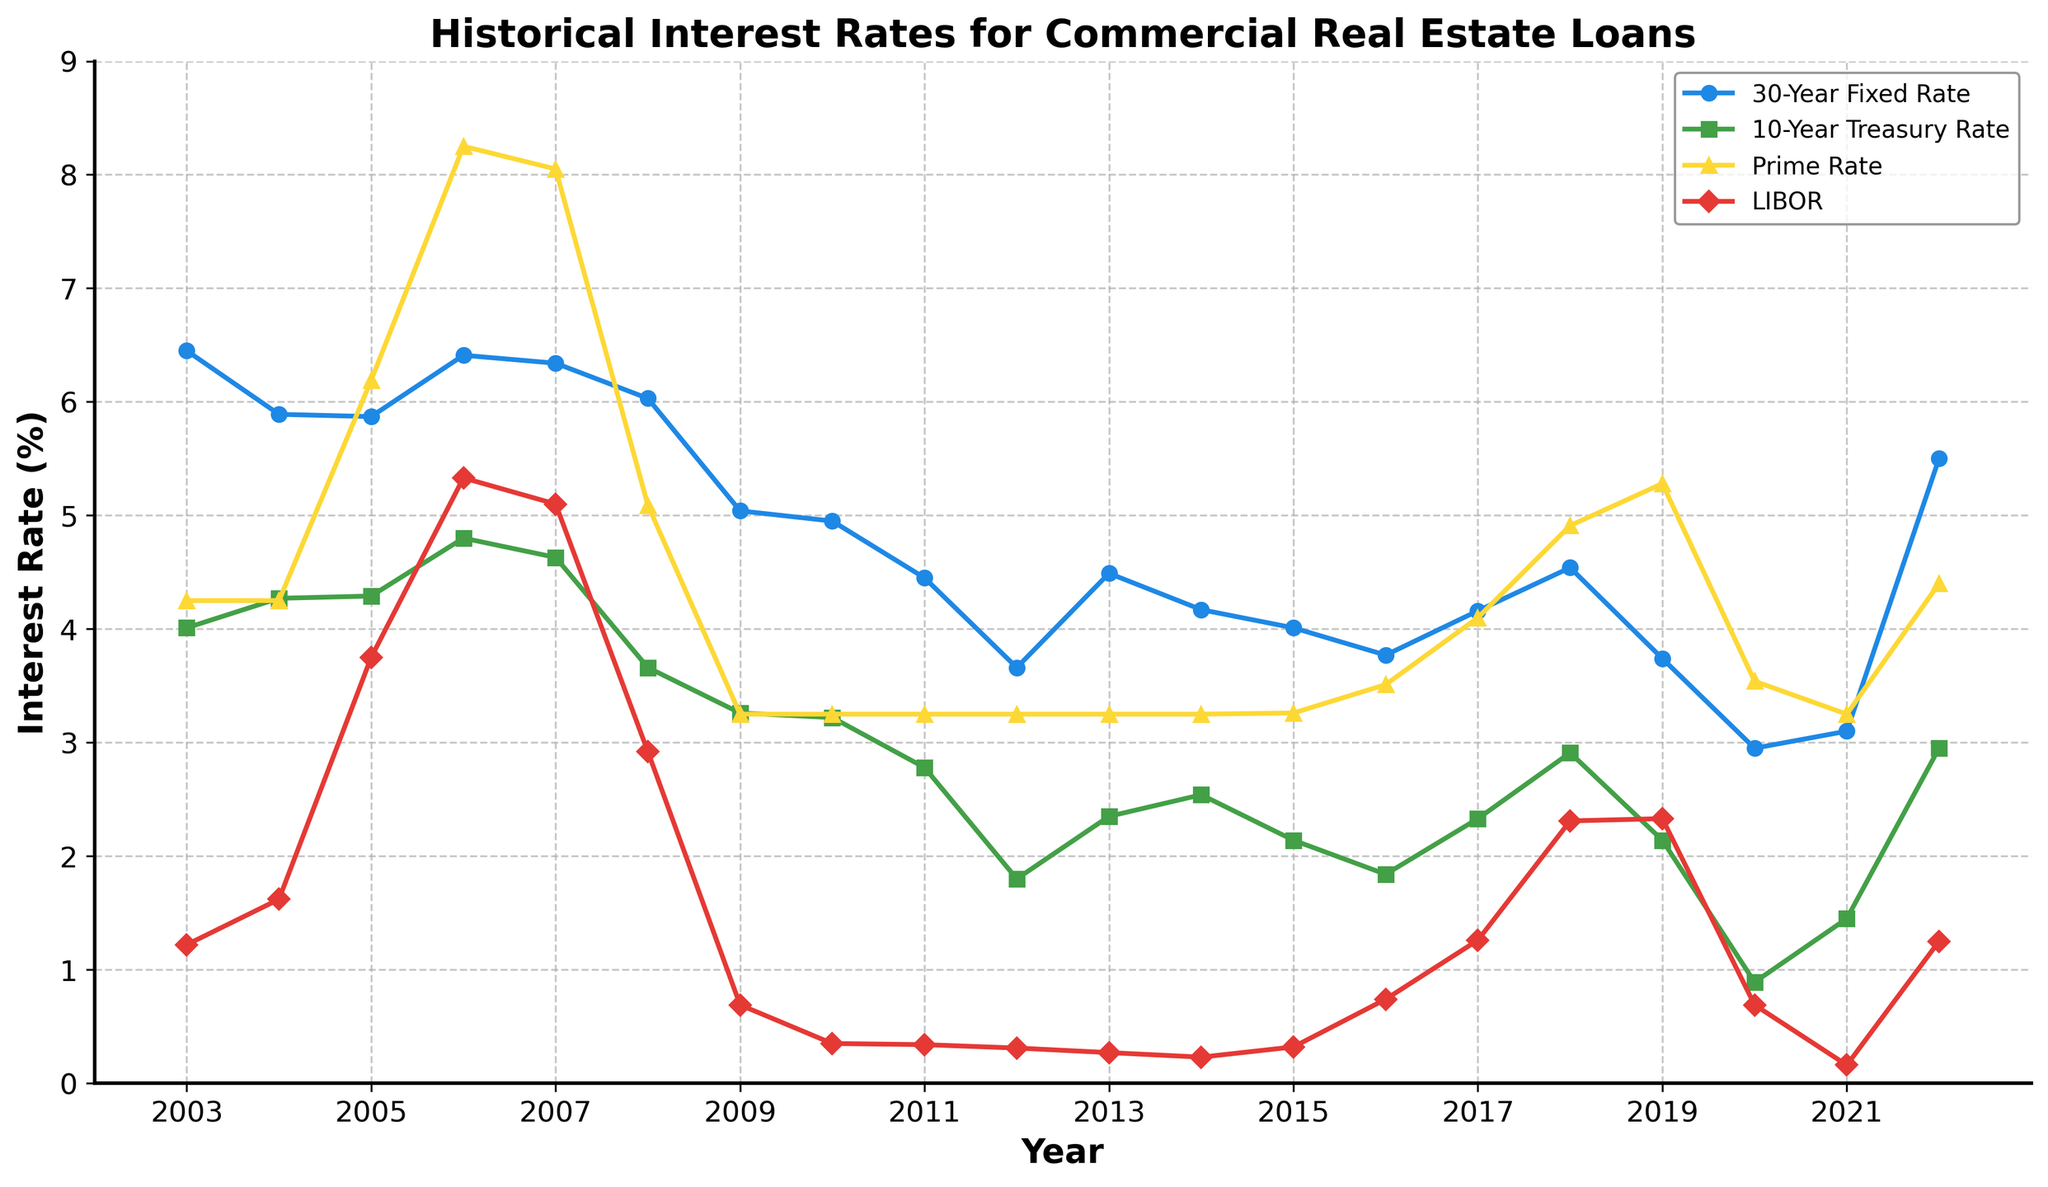What was the highest interest rate for the 30-Year Fixed Rate over the past 20 years? Look at the line representing the 30-Year Fixed Rate. The highest point on this line indicates the highest interest rate.
Answer: 6.45 Which year had the lowest LIBOR rate? Observe the points on the line representing LIBOR. The lowest point on this line corresponds to the year with the lowest LIBOR rate.
Answer: 2021 In which year did the Prime Rate and 10-Year Treasury Rate both intersect near their respective peaks? Check where the lines representing the Prime Rate and the 10-Year Treasury Rate intersect near their highest values.
Answer: 2006 Compare the trend of the 30-Year Fixed Rate and the LIBOR rate from 2003 to 2022. Which one saw a larger decrease overall? Calculate the overall change for both by subtracting the values of 2003 from the values of 2022. The one with the larger decrease experienced a larger fall.
Answer: LIBOR During which year did the 10-Year Treasury Rate see the biggest year-over-year decrease? Identify the year-over-year differences for the 10-Year Treasury Rate and spot the largest decrease.
Answer: 2008 What is the average rate of the Prime Rate from 2010 to 2020? Sum the Prime Rates from 2010 to 2020 and divide by the number of years to obtain the average.
Answer: 3.56 In what year did the 30-Year Fixed Rate drop below 4% for the first time? Notice the first point on the 30-Year Fixed Rate line where the value goes below 4%.
Answer: 2012 Between 2010 and 2020, in which year did the LIBOR rate have the highest peak? Locate the highest point for the LIBOR rate between 2010 and 2020.
Answer: 2017 What was the difference in the Prime Rate between 2007 and 2009? Subtract the Prime Rate of 2009 from the Prime Rate of 2007 to find the difference.
Answer: 4.80 What are the colors used to represent each interest rate on the plot? Look at the plot legend and note down the colors corresponding to each interest rate.
Answer: Blue for 30-Year Fixed Rate, Green for 10-Year Treasury Rate, Yellow for Prime Rate, Red for LIBOR 